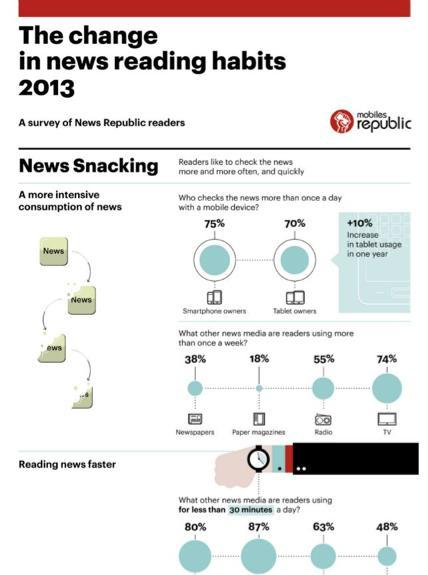What percentage of people check the news for more than once a day in tablets according to the survey of New Republic Readers in 2013?
Answer the question with a short phrase. 70% What percentage of people check the news for more than once a day in smartphones according to the survey of New Republic Readers in 2013? 75% 